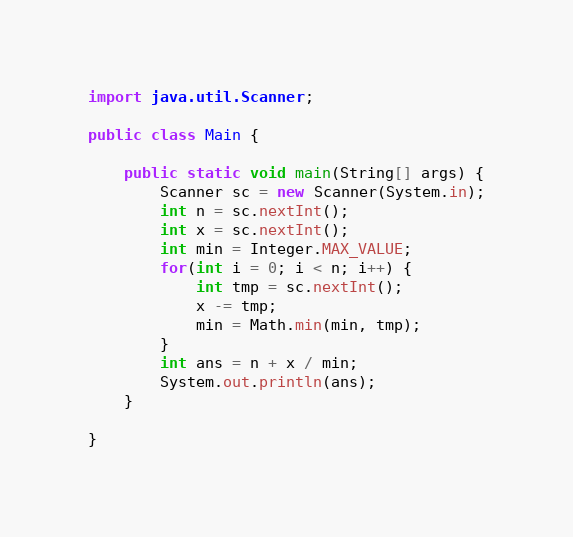<code> <loc_0><loc_0><loc_500><loc_500><_Java_>
import java.util.Scanner;

public class Main {

	public static void main(String[] args) {
		Scanner sc = new Scanner(System.in);
		int n = sc.nextInt();
		int x = sc.nextInt();
		int min = Integer.MAX_VALUE;
		for(int i = 0; i < n; i++) {
			int tmp = sc.nextInt();
			x -= tmp;
			min = Math.min(min, tmp);
		}
		int ans = n + x / min;
		System.out.println(ans);
	}

}
</code> 